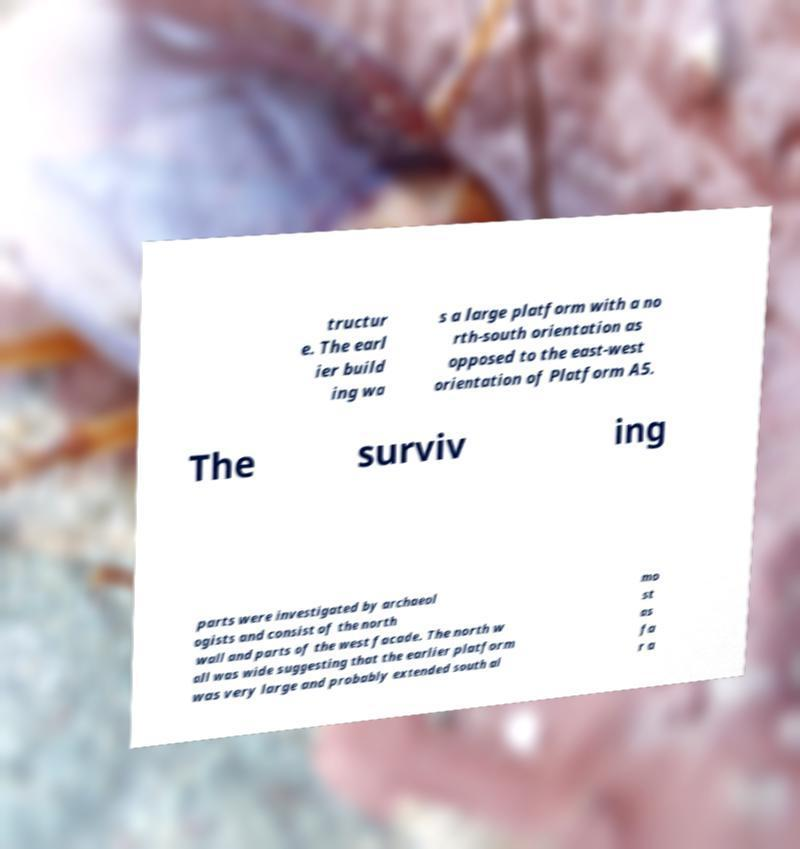Could you extract and type out the text from this image? tructur e. The earl ier build ing wa s a large platform with a no rth-south orientation as opposed to the east-west orientation of Platform A5. The surviv ing parts were investigated by archaeol ogists and consist of the north wall and parts of the west facade. The north w all was wide suggesting that the earlier platform was very large and probably extended south al mo st as fa r a 